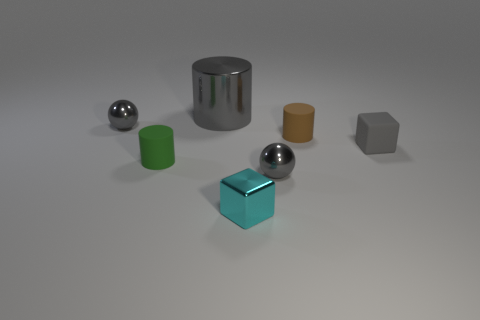Subtract all large cylinders. How many cylinders are left? 2 Subtract 1 cylinders. How many cylinders are left? 2 Add 1 small red shiny cylinders. How many objects exist? 8 Subtract all purple cylinders. Subtract all yellow spheres. How many cylinders are left? 3 Subtract all cylinders. How many objects are left? 4 Subtract all tiny cyan shiny cubes. Subtract all big matte spheres. How many objects are left? 6 Add 7 tiny brown matte cylinders. How many tiny brown matte cylinders are left? 8 Add 4 small brown metallic blocks. How many small brown metallic blocks exist? 4 Subtract 0 red spheres. How many objects are left? 7 